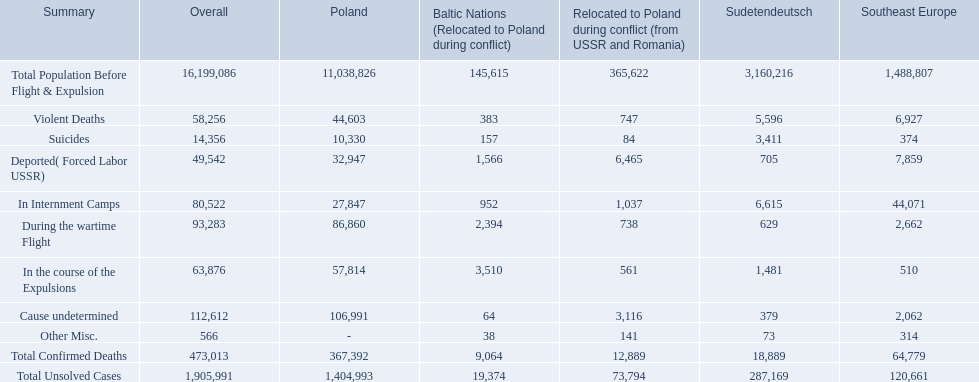How many deaths did the baltic states have in each category? 145,615, 383, 157, 1,566, 952, 2,394, 3,510, 64, 38, 9,064, 19,374. How many cause undetermined deaths did baltic states have? 64. How many other miscellaneous deaths did baltic states have? 38. Which is higher in deaths, cause undetermined or other miscellaneous? Cause undetermined. 